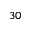Convert formula to latex. <formula><loc_0><loc_0><loc_500><loc_500>3 0</formula> 